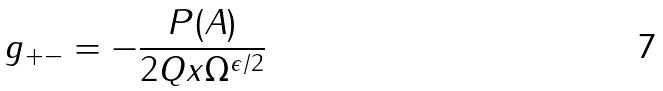<formula> <loc_0><loc_0><loc_500><loc_500>g _ { + - } = - \frac { P ( A ) } { 2 Q x \Omega ^ { \epsilon / 2 } }</formula> 